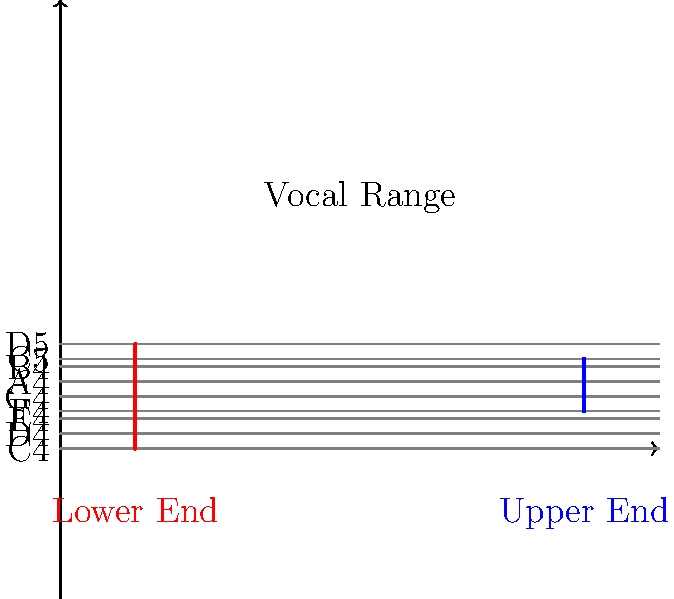Based on the musical staff representation of Joanna Cotten's vocal range, what is the approximate span of her vocal range in octaves? To determine Joanna Cotten's vocal range in octaves, we need to follow these steps:

1. Identify the lower end of her range on the staff:
   The red line starts at C4 (middle C).

2. Identify the upper end of her range on the staff:
   The blue line ends at C5 (one octave above middle C).

3. Calculate the span:
   - From C4 to C5 is exactly one octave.
   - The blue line extends slightly above C5, indicating she can reach notes a bit higher, possibly up to D5.

4. Estimate the total range:
   - The span from C4 to D5 is slightly more than one octave.
   - In musical terms, this would be described as "just over an octave" or "approximately 1.1 octaves".

Given Joanna Cotten's reputation as a powerful vocalist with roots in country and soul music, this range is consistent with her ability to hit both low and high notes effectively in her performances.
Answer: Approximately 1.1 octaves 